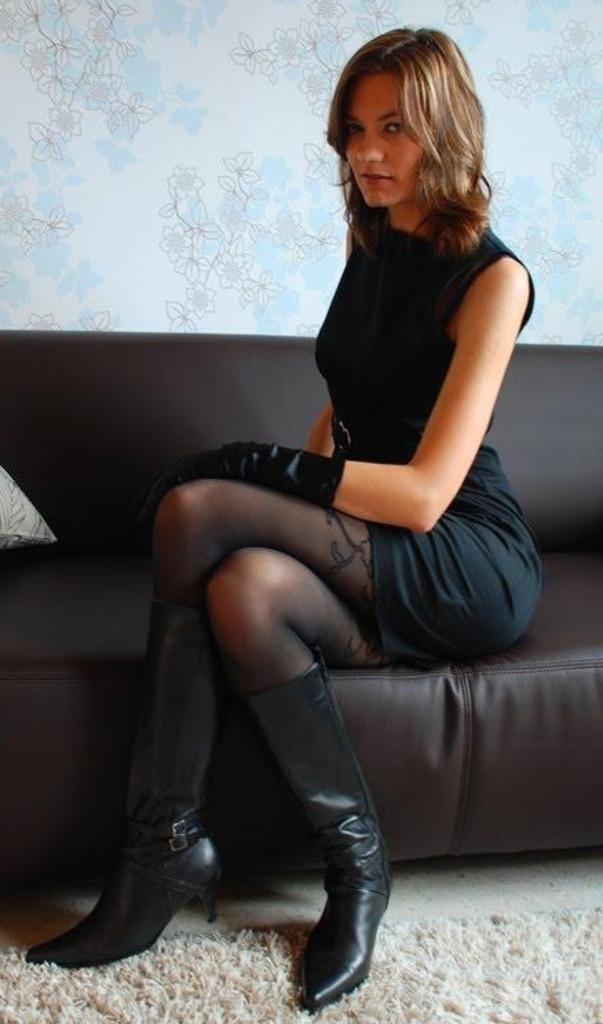What is the woman in the image doing? The woman is seated on the sofa in the image. What is the woman wearing? The woman is wearing a black dress. Can you describe any other objects in the image? There is a cushion visible in the image, and there is a carpet on the floor. What can be seen on the wall in the image? There is a design on the wall in the image. How many sheep are present in the image? There are no sheep present in the image. Is the woman holding an umbrella in the image? There is no umbrella visible in the image. 